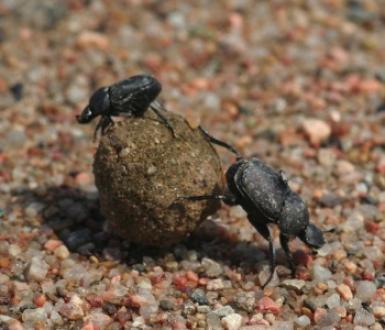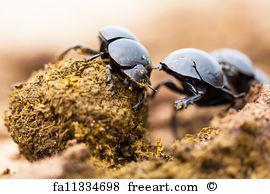The first image is the image on the left, the second image is the image on the right. Assess this claim about the two images: "Exactly one black beetle is shown in each image with its back appendages on a round rocky particle and at least one front appendage on the ground.". Correct or not? Answer yes or no. No. The first image is the image on the left, the second image is the image on the right. Analyze the images presented: Is the assertion "Each image shows exactly one beetle in contact with one round dung ball." valid? Answer yes or no. No. 